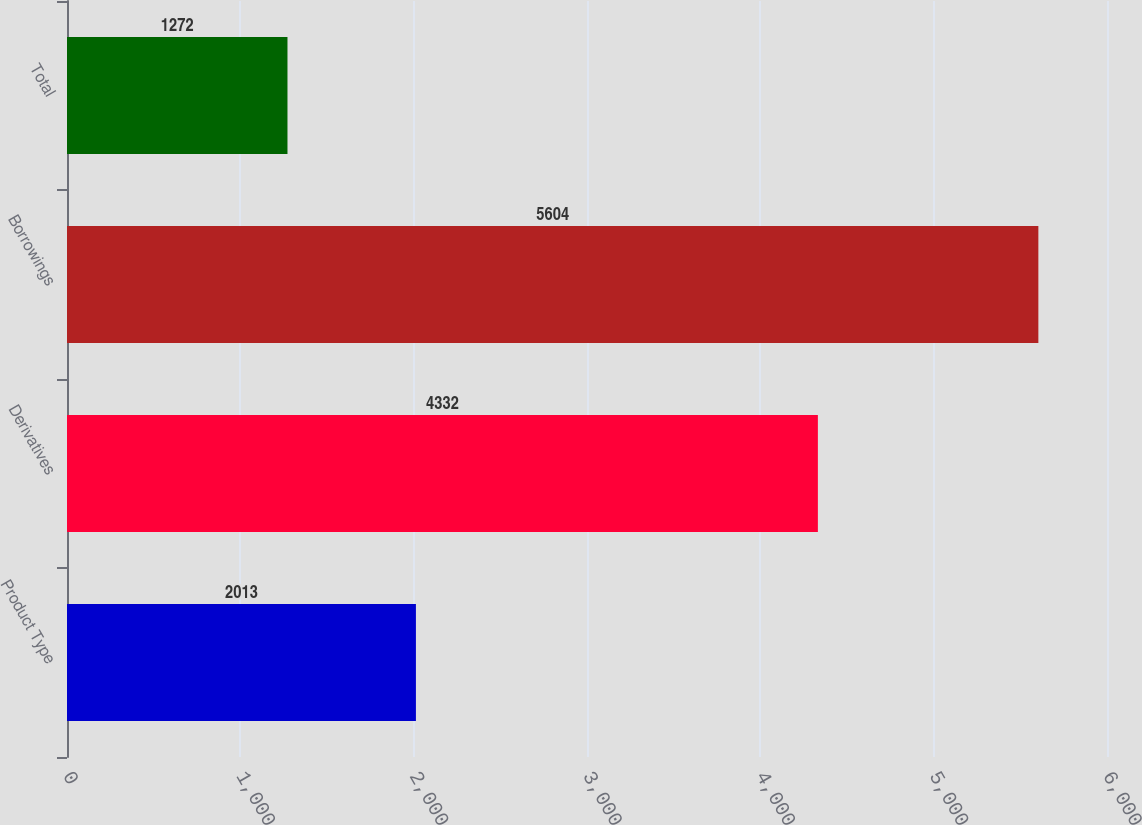Convert chart to OTSL. <chart><loc_0><loc_0><loc_500><loc_500><bar_chart><fcel>Product Type<fcel>Derivatives<fcel>Borrowings<fcel>Total<nl><fcel>2013<fcel>4332<fcel>5604<fcel>1272<nl></chart> 